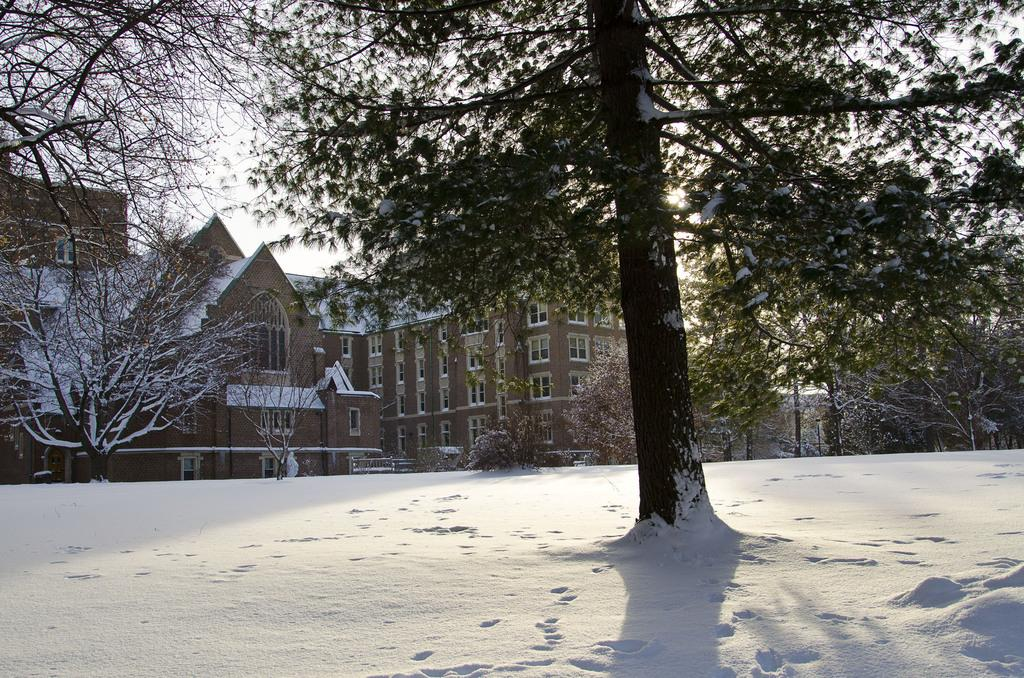What is the condition of the trees in the image? The trees are covered with snow. What is the condition of the houses in the image? The houses are covered with snow. What is the condition of the roads in the image? The roads are covered with snow. What is the source of light in the image? There is sunlight in the image. Where can the crowd be seen in the image? There is no crowd present in the image. What type of needle is used to sew the jeans in the image? There are no jeans or needles present in the image. 